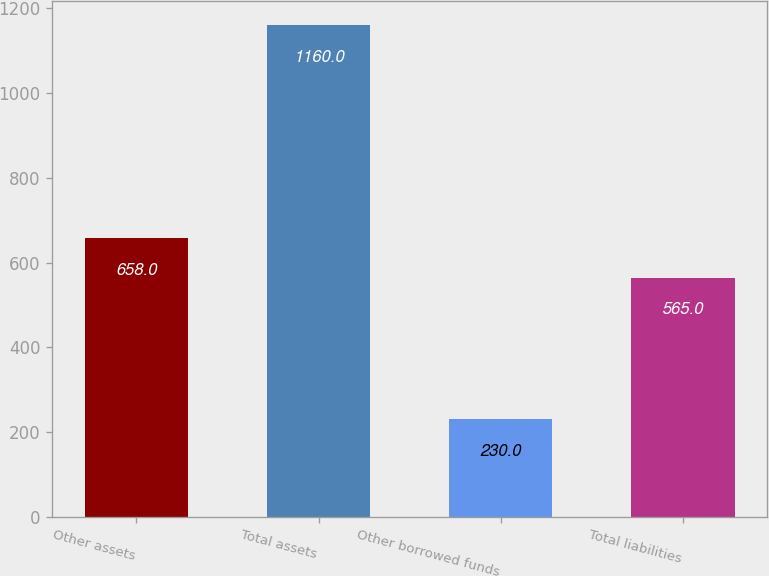Convert chart. <chart><loc_0><loc_0><loc_500><loc_500><bar_chart><fcel>Other assets<fcel>Total assets<fcel>Other borrowed funds<fcel>Total liabilities<nl><fcel>658<fcel>1160<fcel>230<fcel>565<nl></chart> 